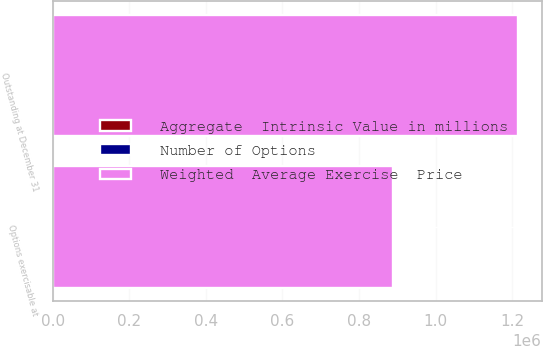Convert chart to OTSL. <chart><loc_0><loc_0><loc_500><loc_500><stacked_bar_chart><ecel><fcel>Outstanding at December 31<fcel>Options exercisable at<nl><fcel>Weighted  Average Exercise  Price<fcel>1.21548e+06<fcel>888061<nl><fcel>Number of Options<fcel>192.63<fcel>152.23<nl><fcel>Aggregate  Intrinsic Value in millions<fcel>274.6<fcel>236.5<nl></chart> 